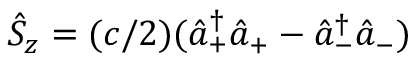Convert formula to latex. <formula><loc_0><loc_0><loc_500><loc_500>\hat { S } _ { z } = ( c / 2 ) ( \hat { a } _ { + } ^ { \dagger } \hat { a } _ { + } - \hat { a } _ { - } ^ { \dagger } \hat { a } _ { - } )</formula> 